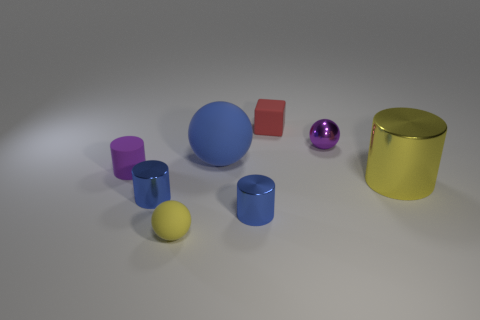Add 2 cylinders. How many objects exist? 10 Subtract all blocks. How many objects are left? 7 Add 1 tiny rubber cubes. How many tiny rubber cubes are left? 2 Add 3 cylinders. How many cylinders exist? 7 Subtract 0 blue blocks. How many objects are left? 8 Subtract all large yellow rubber cylinders. Subtract all small red cubes. How many objects are left? 7 